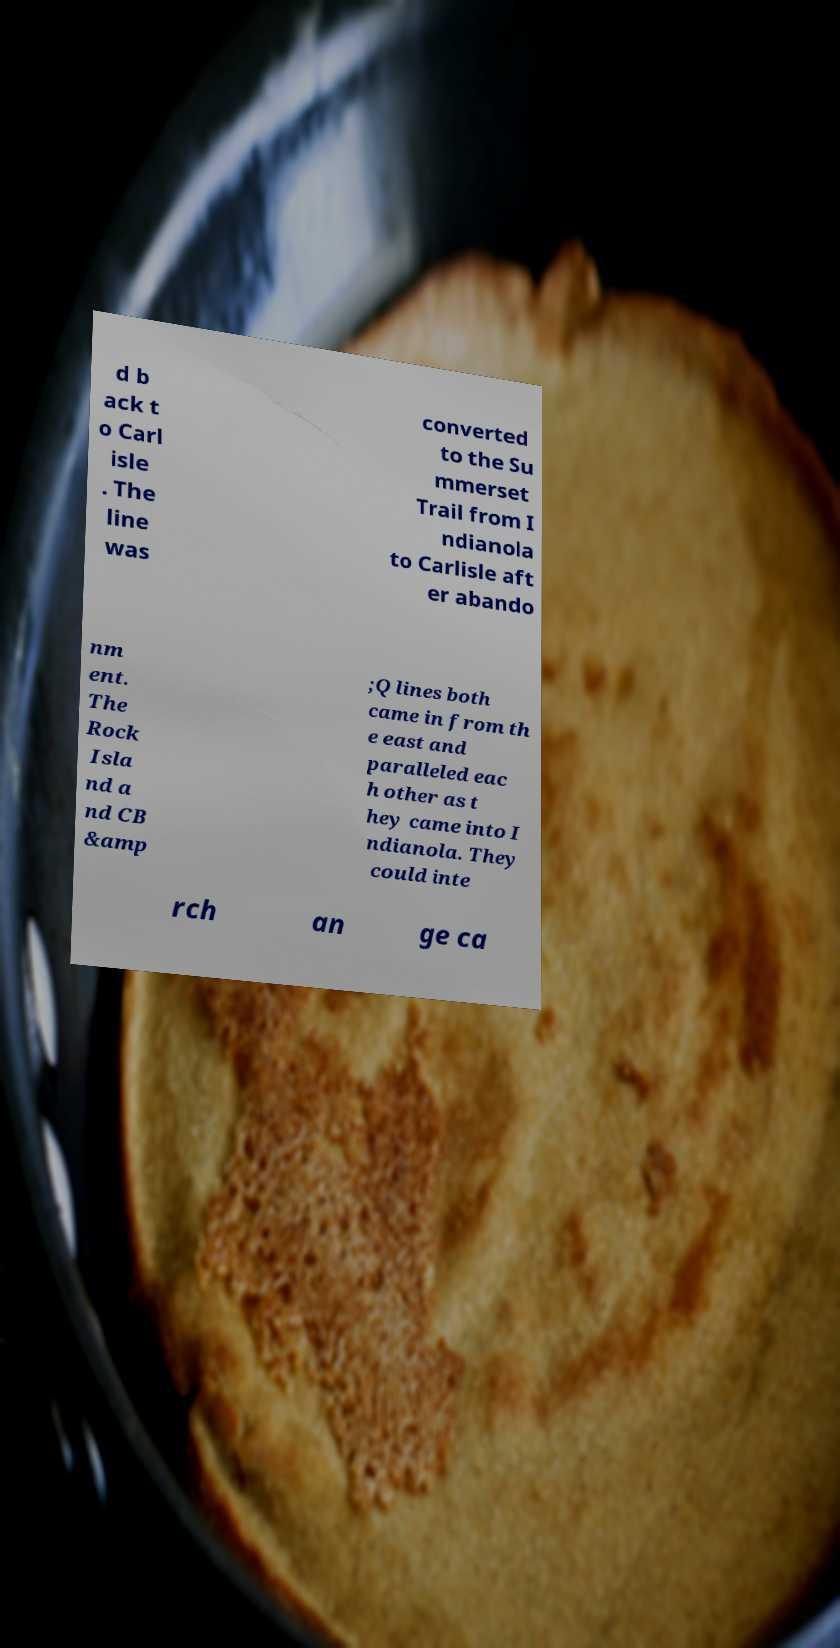Can you accurately transcribe the text from the provided image for me? d b ack t o Carl isle . The line was converted to the Su mmerset Trail from I ndianola to Carlisle aft er abando nm ent. The Rock Isla nd a nd CB &amp ;Q lines both came in from th e east and paralleled eac h other as t hey came into I ndianola. They could inte rch an ge ca 